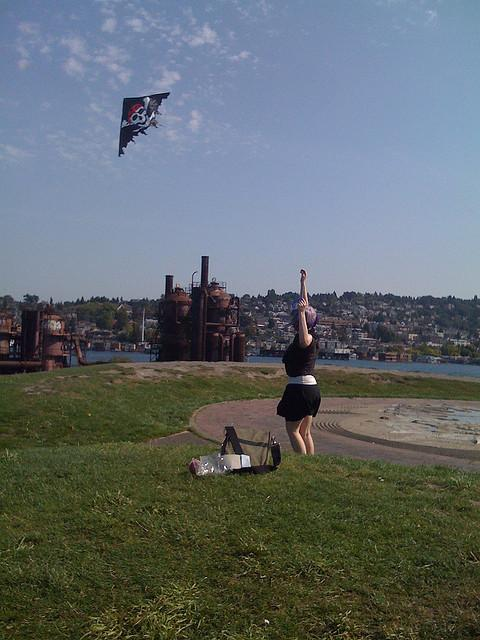How does the woman direct here kite and control it?

Choices:
A) magic
B) drone
C) string
D) wand string 